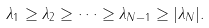Convert formula to latex. <formula><loc_0><loc_0><loc_500><loc_500>\lambda _ { 1 } \geq \lambda _ { 2 } \geq \cdots \geq \lambda _ { N - 1 } \geq | \lambda _ { N } | .</formula> 